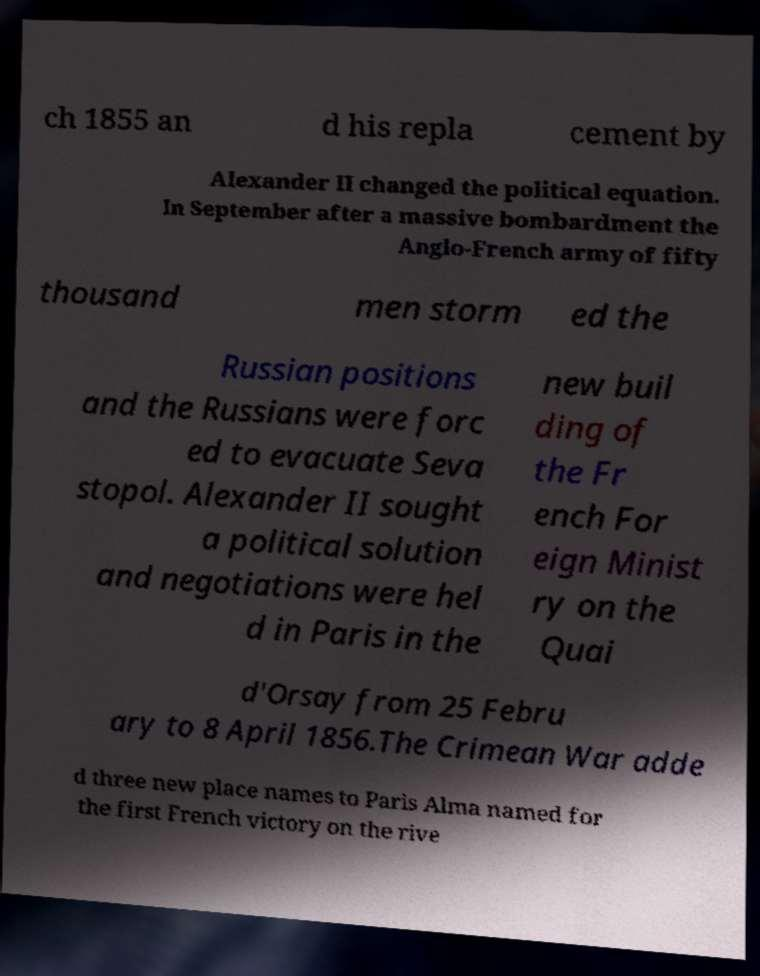For documentation purposes, I need the text within this image transcribed. Could you provide that? ch 1855 an d his repla cement by Alexander II changed the political equation. In September after a massive bombardment the Anglo-French army of fifty thousand men storm ed the Russian positions and the Russians were forc ed to evacuate Seva stopol. Alexander II sought a political solution and negotiations were hel d in Paris in the new buil ding of the Fr ench For eign Minist ry on the Quai d'Orsay from 25 Febru ary to 8 April 1856.The Crimean War adde d three new place names to Paris Alma named for the first French victory on the rive 